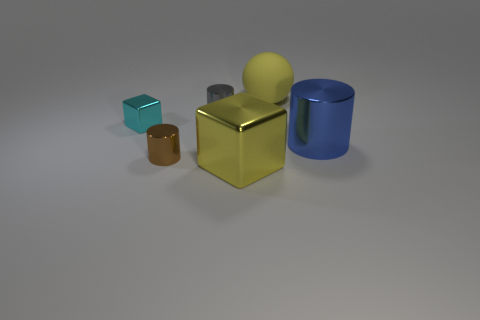There is a big cube that is the same color as the sphere; what is it made of?
Ensure brevity in your answer.  Metal. What number of large yellow spheres have the same material as the large blue cylinder?
Your answer should be very brief. 0. Is the size of the cylinder behind the blue metallic cylinder the same as the big blue metallic object?
Offer a very short reply. No. There is a tiny cube that is the same material as the large block; what color is it?
Keep it short and to the point. Cyan. Is there anything else that has the same size as the yellow matte ball?
Your response must be concise. Yes. There is a small brown object; how many big metal things are to the left of it?
Offer a terse response. 0. There is a metallic object that is right of the big yellow shiny thing; does it have the same color as the tiny metal cylinder that is in front of the small gray cylinder?
Ensure brevity in your answer.  No. What color is the other big shiny thing that is the same shape as the gray metallic thing?
Your answer should be compact. Blue. Is there anything else that is the same shape as the gray thing?
Ensure brevity in your answer.  Yes. There is a big object behind the tiny cyan shiny thing; is it the same shape as the large yellow object that is in front of the blue cylinder?
Your answer should be compact. No. 